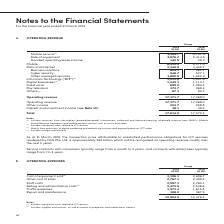According to Singapore Telecommunications's financial document, What is the content of this note 4? According to the financial document, Operating Revenue. The relevant text states: "4. OPERATING REVENUE..." Also, What forms part of the revenue under "Digital Businesses"? Mainly from provisions of digital marketing and advertising services and regional premium OTT video.. The document states: "(3) Mainly from provisions of digital marketing and advertising services and regional premium OTT video...." Also, What is the transaction price attributable to unsatisfied performance obligations for ICT services rendered by NCS Pte. Ltd.? According to the financial document, S$3 billion. The relevant text states: "rvices rendered by NCS Pte. Ltd. is approximately S$3 billion which will be recognised as operating revenue mostly over the next 5 years. rvices rendered by NCS Pte. Ltd. is approximately S$3 billion ..." Also, How many streams of revenue are there under operating revenue? Counting the relevant items in the document: Mobile,  Data and Internet,  Infocomm Technology,  Digital Businesses,  Fixed voice,  Pay television,  Others, I find 7 instances. The key data points involved are: Data and Internet, Digital Businesses, Fixed voice. Also, can you calculate: How much revenue does the largest 2 sources of revenue streams bring in for Singtel in 2019? Based on the calculation: 8,412.9 + 3,340.9 , the result is 11753.8 (in millions). This is based on the information: "Handset operating lease income 140.5 25.2 Mobile 8,412.9 8,177.0 Data and Internet 3,340.9 3,435.7 Business solutions 604.1 560.7 Cyber security 548.7 527.1 0.5 25.2 Mobile 8,412.9 8,177.0 Data and In..." The key data points involved are: 3,340.9, 8,412.9. Also, can you calculate: What is the average revenue under "Other income" across the 2 years? To answer this question, I need to perform calculations using the financial data. The calculation is: (224.7 + 258.8) / 2, which equals 241.75 (in millions). This is based on the information: "ting revenue 17,371.7 17,268.0 Other income 224.7 258.8 Interest and investment income (see Note 10 ) 38.1 45.5 Operating revenue 17,371.7 17,268.0 Other income 224.7 258.8 Interest and investment inc..." The key data points involved are: 224.7, 258.8. 